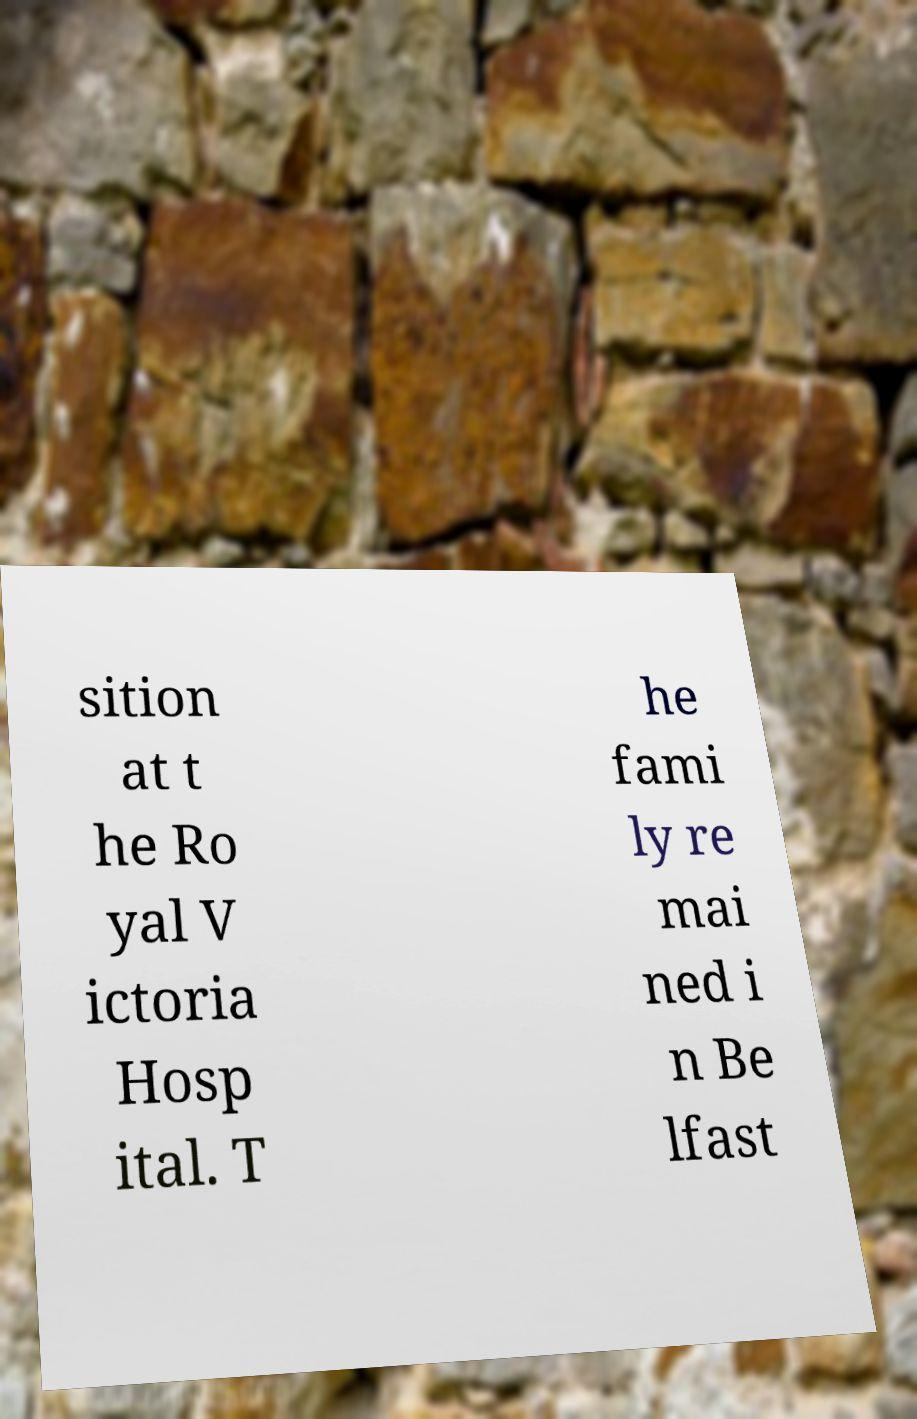Please read and relay the text visible in this image. What does it say? sition at t he Ro yal V ictoria Hosp ital. T he fami ly re mai ned i n Be lfast 